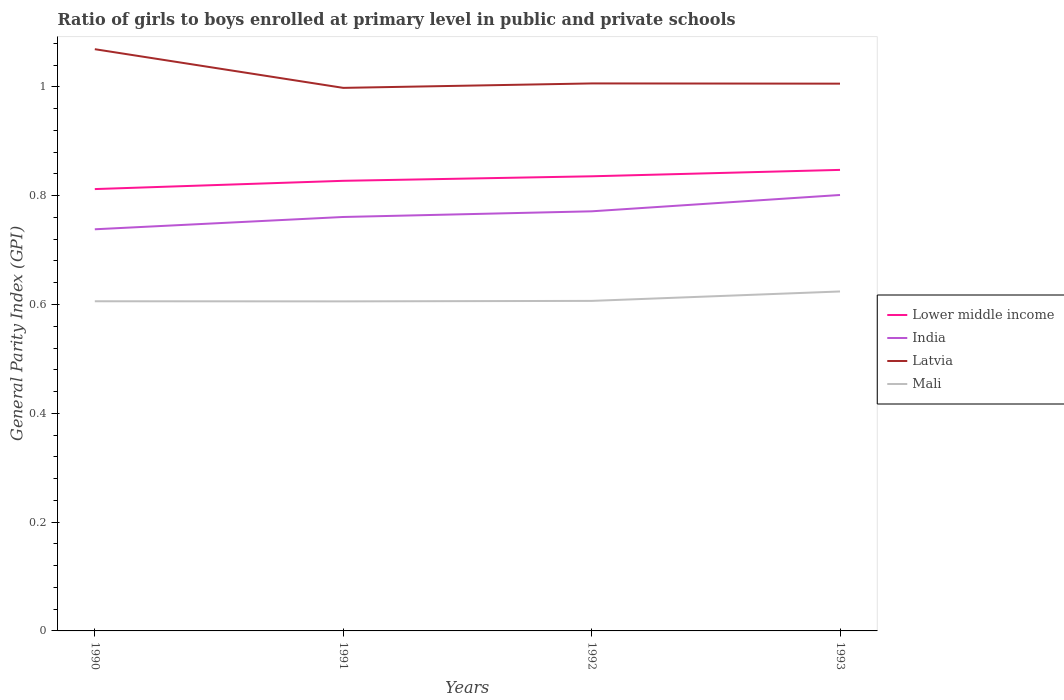Across all years, what is the maximum general parity index in Latvia?
Your answer should be very brief. 1. In which year was the general parity index in India maximum?
Give a very brief answer. 1990. What is the total general parity index in India in the graph?
Ensure brevity in your answer.  -0.03. What is the difference between the highest and the second highest general parity index in Lower middle income?
Your response must be concise. 0.04. Is the general parity index in Lower middle income strictly greater than the general parity index in Mali over the years?
Keep it short and to the point. No. How many years are there in the graph?
Offer a very short reply. 4. Are the values on the major ticks of Y-axis written in scientific E-notation?
Give a very brief answer. No. Does the graph contain any zero values?
Offer a terse response. No. Where does the legend appear in the graph?
Give a very brief answer. Center right. How many legend labels are there?
Ensure brevity in your answer.  4. How are the legend labels stacked?
Make the answer very short. Vertical. What is the title of the graph?
Provide a short and direct response. Ratio of girls to boys enrolled at primary level in public and private schools. Does "Uruguay" appear as one of the legend labels in the graph?
Offer a very short reply. No. What is the label or title of the X-axis?
Offer a very short reply. Years. What is the label or title of the Y-axis?
Offer a very short reply. General Parity Index (GPI). What is the General Parity Index (GPI) in Lower middle income in 1990?
Your answer should be very brief. 0.81. What is the General Parity Index (GPI) of India in 1990?
Keep it short and to the point. 0.74. What is the General Parity Index (GPI) of Latvia in 1990?
Make the answer very short. 1.07. What is the General Parity Index (GPI) of Mali in 1990?
Ensure brevity in your answer.  0.61. What is the General Parity Index (GPI) in Lower middle income in 1991?
Provide a succinct answer. 0.83. What is the General Parity Index (GPI) in India in 1991?
Ensure brevity in your answer.  0.76. What is the General Parity Index (GPI) of Latvia in 1991?
Your response must be concise. 1. What is the General Parity Index (GPI) of Mali in 1991?
Your answer should be compact. 0.61. What is the General Parity Index (GPI) in Lower middle income in 1992?
Keep it short and to the point. 0.84. What is the General Parity Index (GPI) of India in 1992?
Keep it short and to the point. 0.77. What is the General Parity Index (GPI) in Latvia in 1992?
Your answer should be very brief. 1.01. What is the General Parity Index (GPI) in Mali in 1992?
Ensure brevity in your answer.  0.61. What is the General Parity Index (GPI) in Lower middle income in 1993?
Offer a terse response. 0.85. What is the General Parity Index (GPI) of India in 1993?
Your response must be concise. 0.8. What is the General Parity Index (GPI) of Latvia in 1993?
Offer a very short reply. 1.01. What is the General Parity Index (GPI) in Mali in 1993?
Your response must be concise. 0.62. Across all years, what is the maximum General Parity Index (GPI) in Lower middle income?
Offer a very short reply. 0.85. Across all years, what is the maximum General Parity Index (GPI) in India?
Make the answer very short. 0.8. Across all years, what is the maximum General Parity Index (GPI) in Latvia?
Provide a succinct answer. 1.07. Across all years, what is the maximum General Parity Index (GPI) in Mali?
Provide a succinct answer. 0.62. Across all years, what is the minimum General Parity Index (GPI) of Lower middle income?
Give a very brief answer. 0.81. Across all years, what is the minimum General Parity Index (GPI) in India?
Offer a very short reply. 0.74. Across all years, what is the minimum General Parity Index (GPI) of Latvia?
Offer a terse response. 1. Across all years, what is the minimum General Parity Index (GPI) in Mali?
Keep it short and to the point. 0.61. What is the total General Parity Index (GPI) in Lower middle income in the graph?
Offer a very short reply. 3.32. What is the total General Parity Index (GPI) in India in the graph?
Provide a succinct answer. 3.07. What is the total General Parity Index (GPI) of Latvia in the graph?
Ensure brevity in your answer.  4.08. What is the total General Parity Index (GPI) of Mali in the graph?
Offer a terse response. 2.44. What is the difference between the General Parity Index (GPI) in Lower middle income in 1990 and that in 1991?
Make the answer very short. -0.02. What is the difference between the General Parity Index (GPI) in India in 1990 and that in 1991?
Ensure brevity in your answer.  -0.02. What is the difference between the General Parity Index (GPI) of Latvia in 1990 and that in 1991?
Offer a very short reply. 0.07. What is the difference between the General Parity Index (GPI) of Mali in 1990 and that in 1991?
Your answer should be very brief. 0. What is the difference between the General Parity Index (GPI) in Lower middle income in 1990 and that in 1992?
Your answer should be compact. -0.02. What is the difference between the General Parity Index (GPI) in India in 1990 and that in 1992?
Offer a terse response. -0.03. What is the difference between the General Parity Index (GPI) in Latvia in 1990 and that in 1992?
Your answer should be compact. 0.06. What is the difference between the General Parity Index (GPI) of Mali in 1990 and that in 1992?
Offer a very short reply. -0. What is the difference between the General Parity Index (GPI) in Lower middle income in 1990 and that in 1993?
Provide a short and direct response. -0.04. What is the difference between the General Parity Index (GPI) in India in 1990 and that in 1993?
Provide a succinct answer. -0.06. What is the difference between the General Parity Index (GPI) of Latvia in 1990 and that in 1993?
Your answer should be compact. 0.06. What is the difference between the General Parity Index (GPI) in Mali in 1990 and that in 1993?
Your answer should be very brief. -0.02. What is the difference between the General Parity Index (GPI) in Lower middle income in 1991 and that in 1992?
Give a very brief answer. -0.01. What is the difference between the General Parity Index (GPI) in India in 1991 and that in 1992?
Give a very brief answer. -0.01. What is the difference between the General Parity Index (GPI) of Latvia in 1991 and that in 1992?
Provide a succinct answer. -0.01. What is the difference between the General Parity Index (GPI) in Mali in 1991 and that in 1992?
Give a very brief answer. -0. What is the difference between the General Parity Index (GPI) of Lower middle income in 1991 and that in 1993?
Offer a terse response. -0.02. What is the difference between the General Parity Index (GPI) in India in 1991 and that in 1993?
Offer a terse response. -0.04. What is the difference between the General Parity Index (GPI) in Latvia in 1991 and that in 1993?
Make the answer very short. -0.01. What is the difference between the General Parity Index (GPI) of Mali in 1991 and that in 1993?
Give a very brief answer. -0.02. What is the difference between the General Parity Index (GPI) in Lower middle income in 1992 and that in 1993?
Offer a terse response. -0.01. What is the difference between the General Parity Index (GPI) of India in 1992 and that in 1993?
Provide a succinct answer. -0.03. What is the difference between the General Parity Index (GPI) in Latvia in 1992 and that in 1993?
Offer a very short reply. 0. What is the difference between the General Parity Index (GPI) of Mali in 1992 and that in 1993?
Offer a terse response. -0.02. What is the difference between the General Parity Index (GPI) in Lower middle income in 1990 and the General Parity Index (GPI) in India in 1991?
Provide a short and direct response. 0.05. What is the difference between the General Parity Index (GPI) of Lower middle income in 1990 and the General Parity Index (GPI) of Latvia in 1991?
Make the answer very short. -0.19. What is the difference between the General Parity Index (GPI) in Lower middle income in 1990 and the General Parity Index (GPI) in Mali in 1991?
Your response must be concise. 0.21. What is the difference between the General Parity Index (GPI) of India in 1990 and the General Parity Index (GPI) of Latvia in 1991?
Make the answer very short. -0.26. What is the difference between the General Parity Index (GPI) in India in 1990 and the General Parity Index (GPI) in Mali in 1991?
Make the answer very short. 0.13. What is the difference between the General Parity Index (GPI) in Latvia in 1990 and the General Parity Index (GPI) in Mali in 1991?
Make the answer very short. 0.46. What is the difference between the General Parity Index (GPI) in Lower middle income in 1990 and the General Parity Index (GPI) in India in 1992?
Your answer should be very brief. 0.04. What is the difference between the General Parity Index (GPI) in Lower middle income in 1990 and the General Parity Index (GPI) in Latvia in 1992?
Offer a terse response. -0.19. What is the difference between the General Parity Index (GPI) of Lower middle income in 1990 and the General Parity Index (GPI) of Mali in 1992?
Offer a terse response. 0.21. What is the difference between the General Parity Index (GPI) in India in 1990 and the General Parity Index (GPI) in Latvia in 1992?
Your response must be concise. -0.27. What is the difference between the General Parity Index (GPI) of India in 1990 and the General Parity Index (GPI) of Mali in 1992?
Offer a terse response. 0.13. What is the difference between the General Parity Index (GPI) in Latvia in 1990 and the General Parity Index (GPI) in Mali in 1992?
Keep it short and to the point. 0.46. What is the difference between the General Parity Index (GPI) of Lower middle income in 1990 and the General Parity Index (GPI) of India in 1993?
Make the answer very short. 0.01. What is the difference between the General Parity Index (GPI) in Lower middle income in 1990 and the General Parity Index (GPI) in Latvia in 1993?
Make the answer very short. -0.19. What is the difference between the General Parity Index (GPI) in Lower middle income in 1990 and the General Parity Index (GPI) in Mali in 1993?
Provide a short and direct response. 0.19. What is the difference between the General Parity Index (GPI) in India in 1990 and the General Parity Index (GPI) in Latvia in 1993?
Offer a terse response. -0.27. What is the difference between the General Parity Index (GPI) of India in 1990 and the General Parity Index (GPI) of Mali in 1993?
Keep it short and to the point. 0.11. What is the difference between the General Parity Index (GPI) in Latvia in 1990 and the General Parity Index (GPI) in Mali in 1993?
Your answer should be very brief. 0.45. What is the difference between the General Parity Index (GPI) in Lower middle income in 1991 and the General Parity Index (GPI) in India in 1992?
Make the answer very short. 0.06. What is the difference between the General Parity Index (GPI) in Lower middle income in 1991 and the General Parity Index (GPI) in Latvia in 1992?
Give a very brief answer. -0.18. What is the difference between the General Parity Index (GPI) of Lower middle income in 1991 and the General Parity Index (GPI) of Mali in 1992?
Your response must be concise. 0.22. What is the difference between the General Parity Index (GPI) in India in 1991 and the General Parity Index (GPI) in Latvia in 1992?
Make the answer very short. -0.25. What is the difference between the General Parity Index (GPI) in India in 1991 and the General Parity Index (GPI) in Mali in 1992?
Give a very brief answer. 0.15. What is the difference between the General Parity Index (GPI) of Latvia in 1991 and the General Parity Index (GPI) of Mali in 1992?
Your answer should be very brief. 0.39. What is the difference between the General Parity Index (GPI) of Lower middle income in 1991 and the General Parity Index (GPI) of India in 1993?
Your answer should be compact. 0.03. What is the difference between the General Parity Index (GPI) of Lower middle income in 1991 and the General Parity Index (GPI) of Latvia in 1993?
Make the answer very short. -0.18. What is the difference between the General Parity Index (GPI) in Lower middle income in 1991 and the General Parity Index (GPI) in Mali in 1993?
Offer a terse response. 0.2. What is the difference between the General Parity Index (GPI) in India in 1991 and the General Parity Index (GPI) in Latvia in 1993?
Your answer should be compact. -0.25. What is the difference between the General Parity Index (GPI) of India in 1991 and the General Parity Index (GPI) of Mali in 1993?
Ensure brevity in your answer.  0.14. What is the difference between the General Parity Index (GPI) in Latvia in 1991 and the General Parity Index (GPI) in Mali in 1993?
Give a very brief answer. 0.37. What is the difference between the General Parity Index (GPI) of Lower middle income in 1992 and the General Parity Index (GPI) of India in 1993?
Offer a very short reply. 0.03. What is the difference between the General Parity Index (GPI) of Lower middle income in 1992 and the General Parity Index (GPI) of Latvia in 1993?
Your response must be concise. -0.17. What is the difference between the General Parity Index (GPI) of Lower middle income in 1992 and the General Parity Index (GPI) of Mali in 1993?
Give a very brief answer. 0.21. What is the difference between the General Parity Index (GPI) of India in 1992 and the General Parity Index (GPI) of Latvia in 1993?
Make the answer very short. -0.23. What is the difference between the General Parity Index (GPI) in India in 1992 and the General Parity Index (GPI) in Mali in 1993?
Provide a short and direct response. 0.15. What is the difference between the General Parity Index (GPI) in Latvia in 1992 and the General Parity Index (GPI) in Mali in 1993?
Your answer should be compact. 0.38. What is the average General Parity Index (GPI) in Lower middle income per year?
Your response must be concise. 0.83. What is the average General Parity Index (GPI) in India per year?
Keep it short and to the point. 0.77. What is the average General Parity Index (GPI) of Mali per year?
Provide a succinct answer. 0.61. In the year 1990, what is the difference between the General Parity Index (GPI) in Lower middle income and General Parity Index (GPI) in India?
Keep it short and to the point. 0.07. In the year 1990, what is the difference between the General Parity Index (GPI) in Lower middle income and General Parity Index (GPI) in Latvia?
Give a very brief answer. -0.26. In the year 1990, what is the difference between the General Parity Index (GPI) of Lower middle income and General Parity Index (GPI) of Mali?
Give a very brief answer. 0.21. In the year 1990, what is the difference between the General Parity Index (GPI) of India and General Parity Index (GPI) of Latvia?
Make the answer very short. -0.33. In the year 1990, what is the difference between the General Parity Index (GPI) in India and General Parity Index (GPI) in Mali?
Provide a short and direct response. 0.13. In the year 1990, what is the difference between the General Parity Index (GPI) in Latvia and General Parity Index (GPI) in Mali?
Offer a terse response. 0.46. In the year 1991, what is the difference between the General Parity Index (GPI) of Lower middle income and General Parity Index (GPI) of India?
Give a very brief answer. 0.07. In the year 1991, what is the difference between the General Parity Index (GPI) in Lower middle income and General Parity Index (GPI) in Latvia?
Make the answer very short. -0.17. In the year 1991, what is the difference between the General Parity Index (GPI) of Lower middle income and General Parity Index (GPI) of Mali?
Offer a terse response. 0.22. In the year 1991, what is the difference between the General Parity Index (GPI) of India and General Parity Index (GPI) of Latvia?
Ensure brevity in your answer.  -0.24. In the year 1991, what is the difference between the General Parity Index (GPI) of India and General Parity Index (GPI) of Mali?
Make the answer very short. 0.16. In the year 1991, what is the difference between the General Parity Index (GPI) in Latvia and General Parity Index (GPI) in Mali?
Ensure brevity in your answer.  0.39. In the year 1992, what is the difference between the General Parity Index (GPI) in Lower middle income and General Parity Index (GPI) in India?
Ensure brevity in your answer.  0.06. In the year 1992, what is the difference between the General Parity Index (GPI) in Lower middle income and General Parity Index (GPI) in Latvia?
Ensure brevity in your answer.  -0.17. In the year 1992, what is the difference between the General Parity Index (GPI) of Lower middle income and General Parity Index (GPI) of Mali?
Offer a very short reply. 0.23. In the year 1992, what is the difference between the General Parity Index (GPI) in India and General Parity Index (GPI) in Latvia?
Keep it short and to the point. -0.24. In the year 1992, what is the difference between the General Parity Index (GPI) in India and General Parity Index (GPI) in Mali?
Provide a short and direct response. 0.16. In the year 1992, what is the difference between the General Parity Index (GPI) of Latvia and General Parity Index (GPI) of Mali?
Keep it short and to the point. 0.4. In the year 1993, what is the difference between the General Parity Index (GPI) of Lower middle income and General Parity Index (GPI) of India?
Ensure brevity in your answer.  0.05. In the year 1993, what is the difference between the General Parity Index (GPI) in Lower middle income and General Parity Index (GPI) in Latvia?
Your answer should be very brief. -0.16. In the year 1993, what is the difference between the General Parity Index (GPI) in Lower middle income and General Parity Index (GPI) in Mali?
Keep it short and to the point. 0.22. In the year 1993, what is the difference between the General Parity Index (GPI) of India and General Parity Index (GPI) of Latvia?
Your response must be concise. -0.2. In the year 1993, what is the difference between the General Parity Index (GPI) of India and General Parity Index (GPI) of Mali?
Your answer should be very brief. 0.18. In the year 1993, what is the difference between the General Parity Index (GPI) in Latvia and General Parity Index (GPI) in Mali?
Offer a very short reply. 0.38. What is the ratio of the General Parity Index (GPI) of Lower middle income in 1990 to that in 1991?
Ensure brevity in your answer.  0.98. What is the ratio of the General Parity Index (GPI) of India in 1990 to that in 1991?
Offer a very short reply. 0.97. What is the ratio of the General Parity Index (GPI) of Latvia in 1990 to that in 1991?
Offer a terse response. 1.07. What is the ratio of the General Parity Index (GPI) in Lower middle income in 1990 to that in 1992?
Keep it short and to the point. 0.97. What is the ratio of the General Parity Index (GPI) of India in 1990 to that in 1992?
Offer a terse response. 0.96. What is the ratio of the General Parity Index (GPI) of Mali in 1990 to that in 1992?
Provide a succinct answer. 1. What is the ratio of the General Parity Index (GPI) in Lower middle income in 1990 to that in 1993?
Provide a short and direct response. 0.96. What is the ratio of the General Parity Index (GPI) of India in 1990 to that in 1993?
Offer a terse response. 0.92. What is the ratio of the General Parity Index (GPI) of Latvia in 1990 to that in 1993?
Offer a very short reply. 1.06. What is the ratio of the General Parity Index (GPI) in Mali in 1990 to that in 1993?
Make the answer very short. 0.97. What is the ratio of the General Parity Index (GPI) in India in 1991 to that in 1992?
Offer a very short reply. 0.99. What is the ratio of the General Parity Index (GPI) in Mali in 1991 to that in 1992?
Your answer should be compact. 1. What is the ratio of the General Parity Index (GPI) of Lower middle income in 1991 to that in 1993?
Make the answer very short. 0.98. What is the ratio of the General Parity Index (GPI) of India in 1991 to that in 1993?
Provide a short and direct response. 0.95. What is the ratio of the General Parity Index (GPI) of Mali in 1991 to that in 1993?
Keep it short and to the point. 0.97. What is the ratio of the General Parity Index (GPI) in Lower middle income in 1992 to that in 1993?
Provide a succinct answer. 0.99. What is the ratio of the General Parity Index (GPI) in India in 1992 to that in 1993?
Provide a short and direct response. 0.96. What is the ratio of the General Parity Index (GPI) of Latvia in 1992 to that in 1993?
Your response must be concise. 1. What is the ratio of the General Parity Index (GPI) in Mali in 1992 to that in 1993?
Provide a short and direct response. 0.97. What is the difference between the highest and the second highest General Parity Index (GPI) of Lower middle income?
Offer a terse response. 0.01. What is the difference between the highest and the second highest General Parity Index (GPI) in Latvia?
Offer a very short reply. 0.06. What is the difference between the highest and the second highest General Parity Index (GPI) of Mali?
Provide a succinct answer. 0.02. What is the difference between the highest and the lowest General Parity Index (GPI) in Lower middle income?
Offer a very short reply. 0.04. What is the difference between the highest and the lowest General Parity Index (GPI) of India?
Keep it short and to the point. 0.06. What is the difference between the highest and the lowest General Parity Index (GPI) in Latvia?
Your answer should be compact. 0.07. What is the difference between the highest and the lowest General Parity Index (GPI) of Mali?
Make the answer very short. 0.02. 